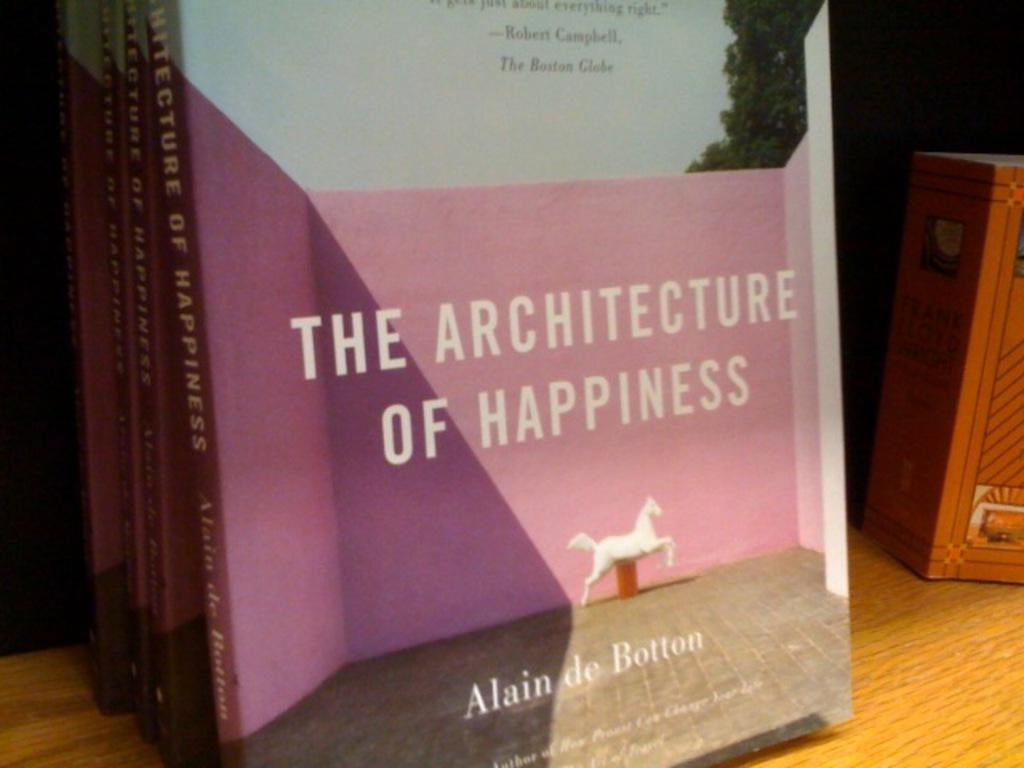Provide a one-sentence caption for the provided image. A stack of Alain De Botton novels are on display at a book store. 